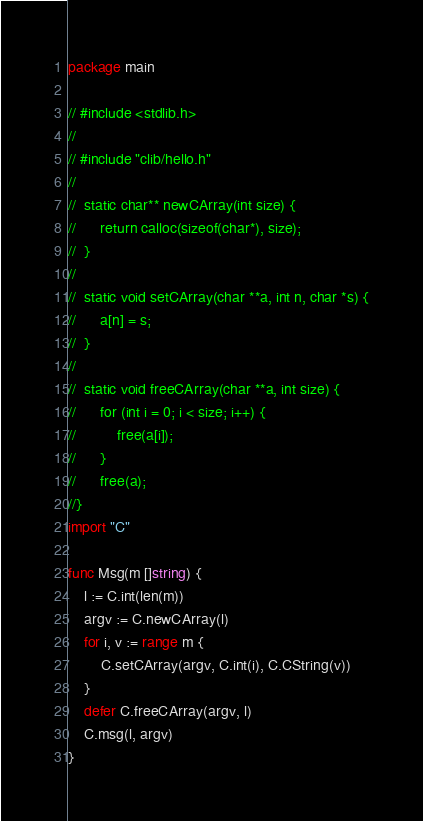<code> <loc_0><loc_0><loc_500><loc_500><_Go_>package main

// #include <stdlib.h>
//
// #include "clib/hello.h"
//
//	static char** newCArray(int size) {
//      return calloc(sizeof(char*), size);
//  }
//
//  static void setCArray(char **a, int n, char *s) {
//      a[n] = s;
//  }
//
//  static void freeCArray(char **a, int size) {
//      for (int i = 0; i < size; i++) {
//          free(a[i]);
//      }
//      free(a);
//}
import "C"

func Msg(m []string) {
	l := C.int(len(m))
	argv := C.newCArray(l)
	for i, v := range m {
		C.setCArray(argv, C.int(i), C.CString(v))
	}
	defer C.freeCArray(argv, l)
	C.msg(l, argv)
}
</code> 